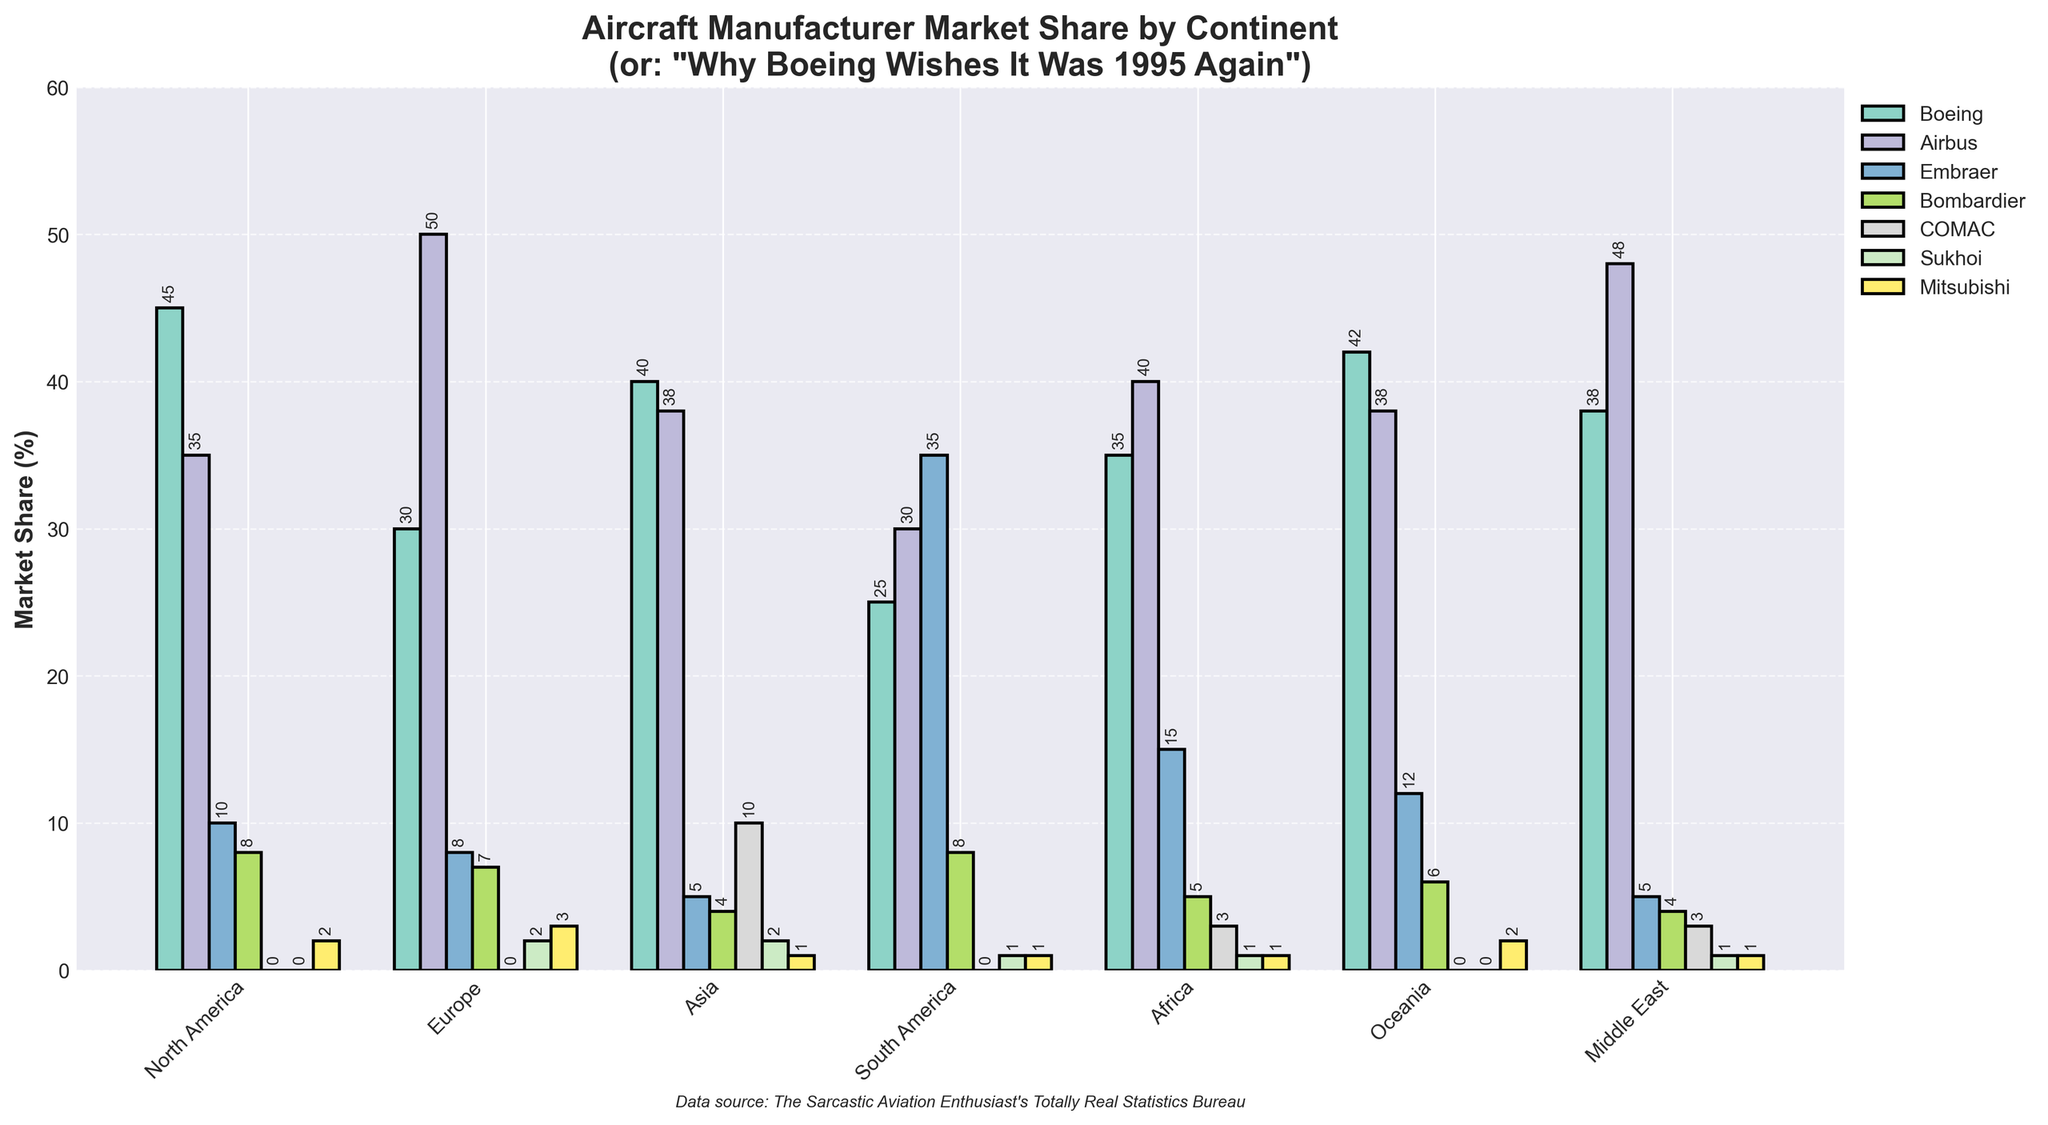Which continent shows the highest market share for Boeing? Looking at the bar chart, we can see the bars representing Boeing's market share across different continents. The highest bar for Boeing is found in North America, where Boeing holds 45%.
Answer: North America Which manufacturer has the largest market share in the Middle East? The bar chart segments the market share data by manufacturer and continent. In the Middle East, Airbus has the highest bar, showing a 48% market share.
Answer: Airbus What is the combined market share of Embraer and Bombardier in South America? In South America, Embraer's market share is 35% and Bombardier's is 8%. Adding them together, we get 35 + 8 = 43%.
Answer: 43% Which continent has the largest share for COMAC, and what is that percentage? Checking the bars for COMAC across all continents, Asia shows the highest bar. The percentage is 10%.
Answer: Asia, 10% Is the market share of Airbus in Africa higher or lower than in Asia? Comparing the bars for Airbus between Africa and Asia, Africa has a market share of 40%, while Asia has 38%. Hence, Africa's share is higher.
Answer: Higher What is the total market share controlled by Boeing, Airbus, and COMAC in Oceania? In Oceania, Boeing’s share is 42%, Airbus's is 38%, and COMAC has 0%. Summing these, we get 42 + 38 + 0 = 80%.
Answer: 80% How does the market share of Sukhoi in Europe compare to that in Africa? By checking the bars for Sukhoi, Europe has a market share of 2%, whereas Africa has 1%. Therefore, Sukhoi’s share is higher in Europe.
Answer: Europe has more Which continent has the lowest market share for Bombardier, and what is the percentage? Among the bars for Bombardier, both Asia and the Middle East show the lowest market share with a percentage of 4%.
Answer: Asia & Middle East, 4% What percentage of market share is held by Mitsubishi in North America, and how does it compare to its share in Asia? In North America, Mitsubishi holds a 2% market share. In Asia, the market share is 1%. Hence, Mitsubishi has a higher market share in North America.
Answer: North America, higher 